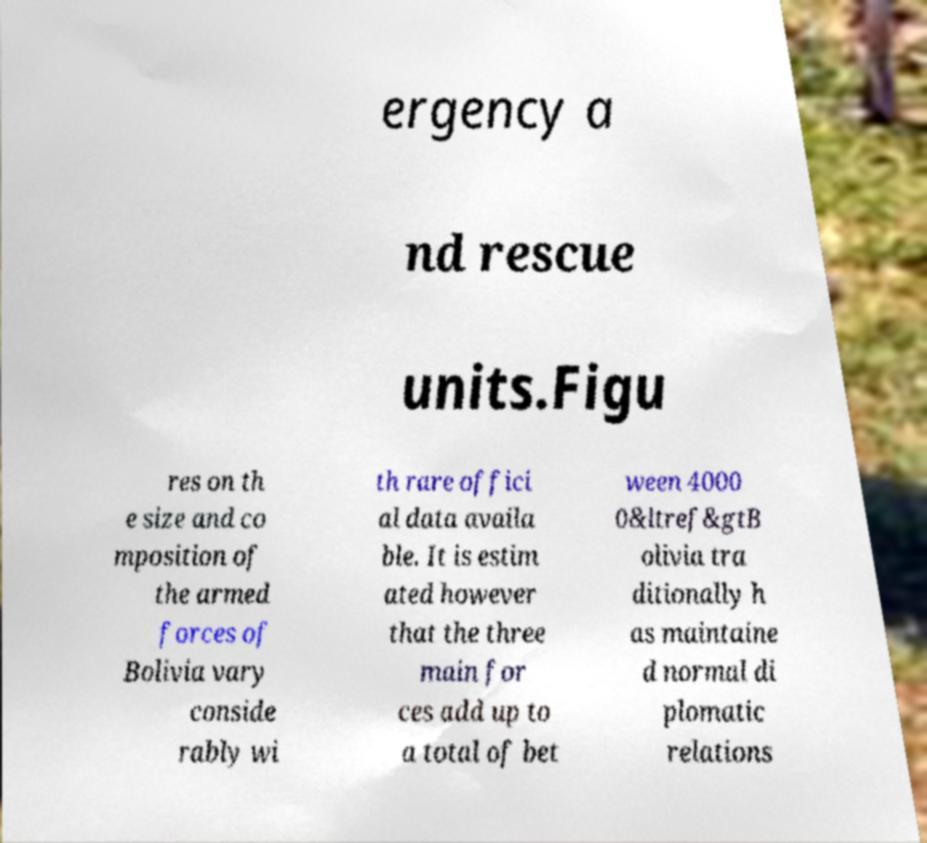Could you extract and type out the text from this image? ergency a nd rescue units.Figu res on th e size and co mposition of the armed forces of Bolivia vary conside rably wi th rare offici al data availa ble. It is estim ated however that the three main for ces add up to a total of bet ween 4000 0&ltref&gtB olivia tra ditionally h as maintaine d normal di plomatic relations 